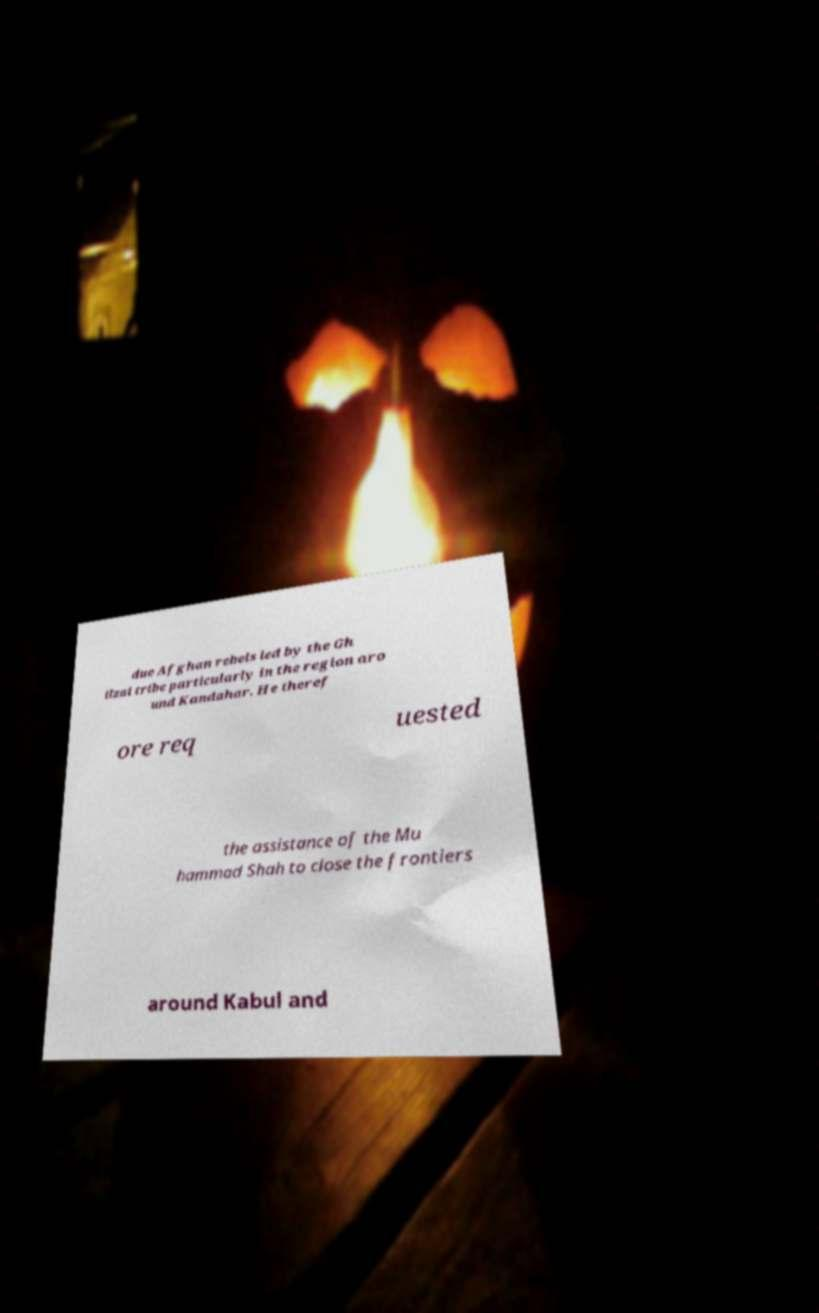I need the written content from this picture converted into text. Can you do that? due Afghan rebels led by the Gh ilzai tribe particularly in the region aro und Kandahar. He theref ore req uested the assistance of the Mu hammad Shah to close the frontiers around Kabul and 